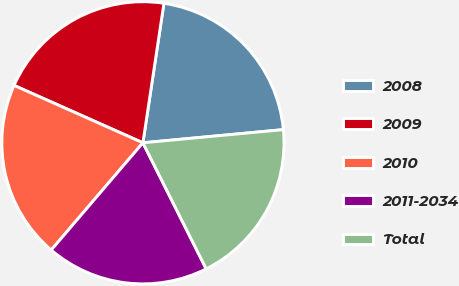Convert chart to OTSL. <chart><loc_0><loc_0><loc_500><loc_500><pie_chart><fcel>2008<fcel>2009<fcel>2010<fcel>2011-2034<fcel>Total<nl><fcel>21.13%<fcel>20.71%<fcel>20.41%<fcel>18.66%<fcel>19.08%<nl></chart> 